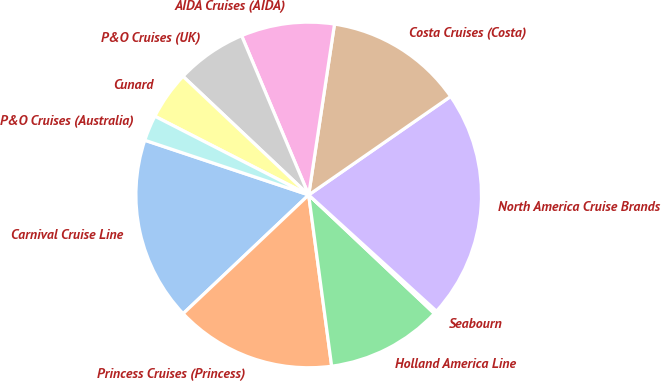<chart> <loc_0><loc_0><loc_500><loc_500><pie_chart><fcel>Carnival Cruise Line<fcel>Princess Cruises (Princess)<fcel>Holland America Line<fcel>Seabourn<fcel>North America Cruise Brands<fcel>Costa Cruises (Costa)<fcel>AIDA Cruises (AIDA)<fcel>P&O Cruises (UK)<fcel>Cunard<fcel>P&O Cruises (Australia)<nl><fcel>17.18%<fcel>15.07%<fcel>10.84%<fcel>0.29%<fcel>21.4%<fcel>12.96%<fcel>8.73%<fcel>6.62%<fcel>4.51%<fcel>2.4%<nl></chart> 